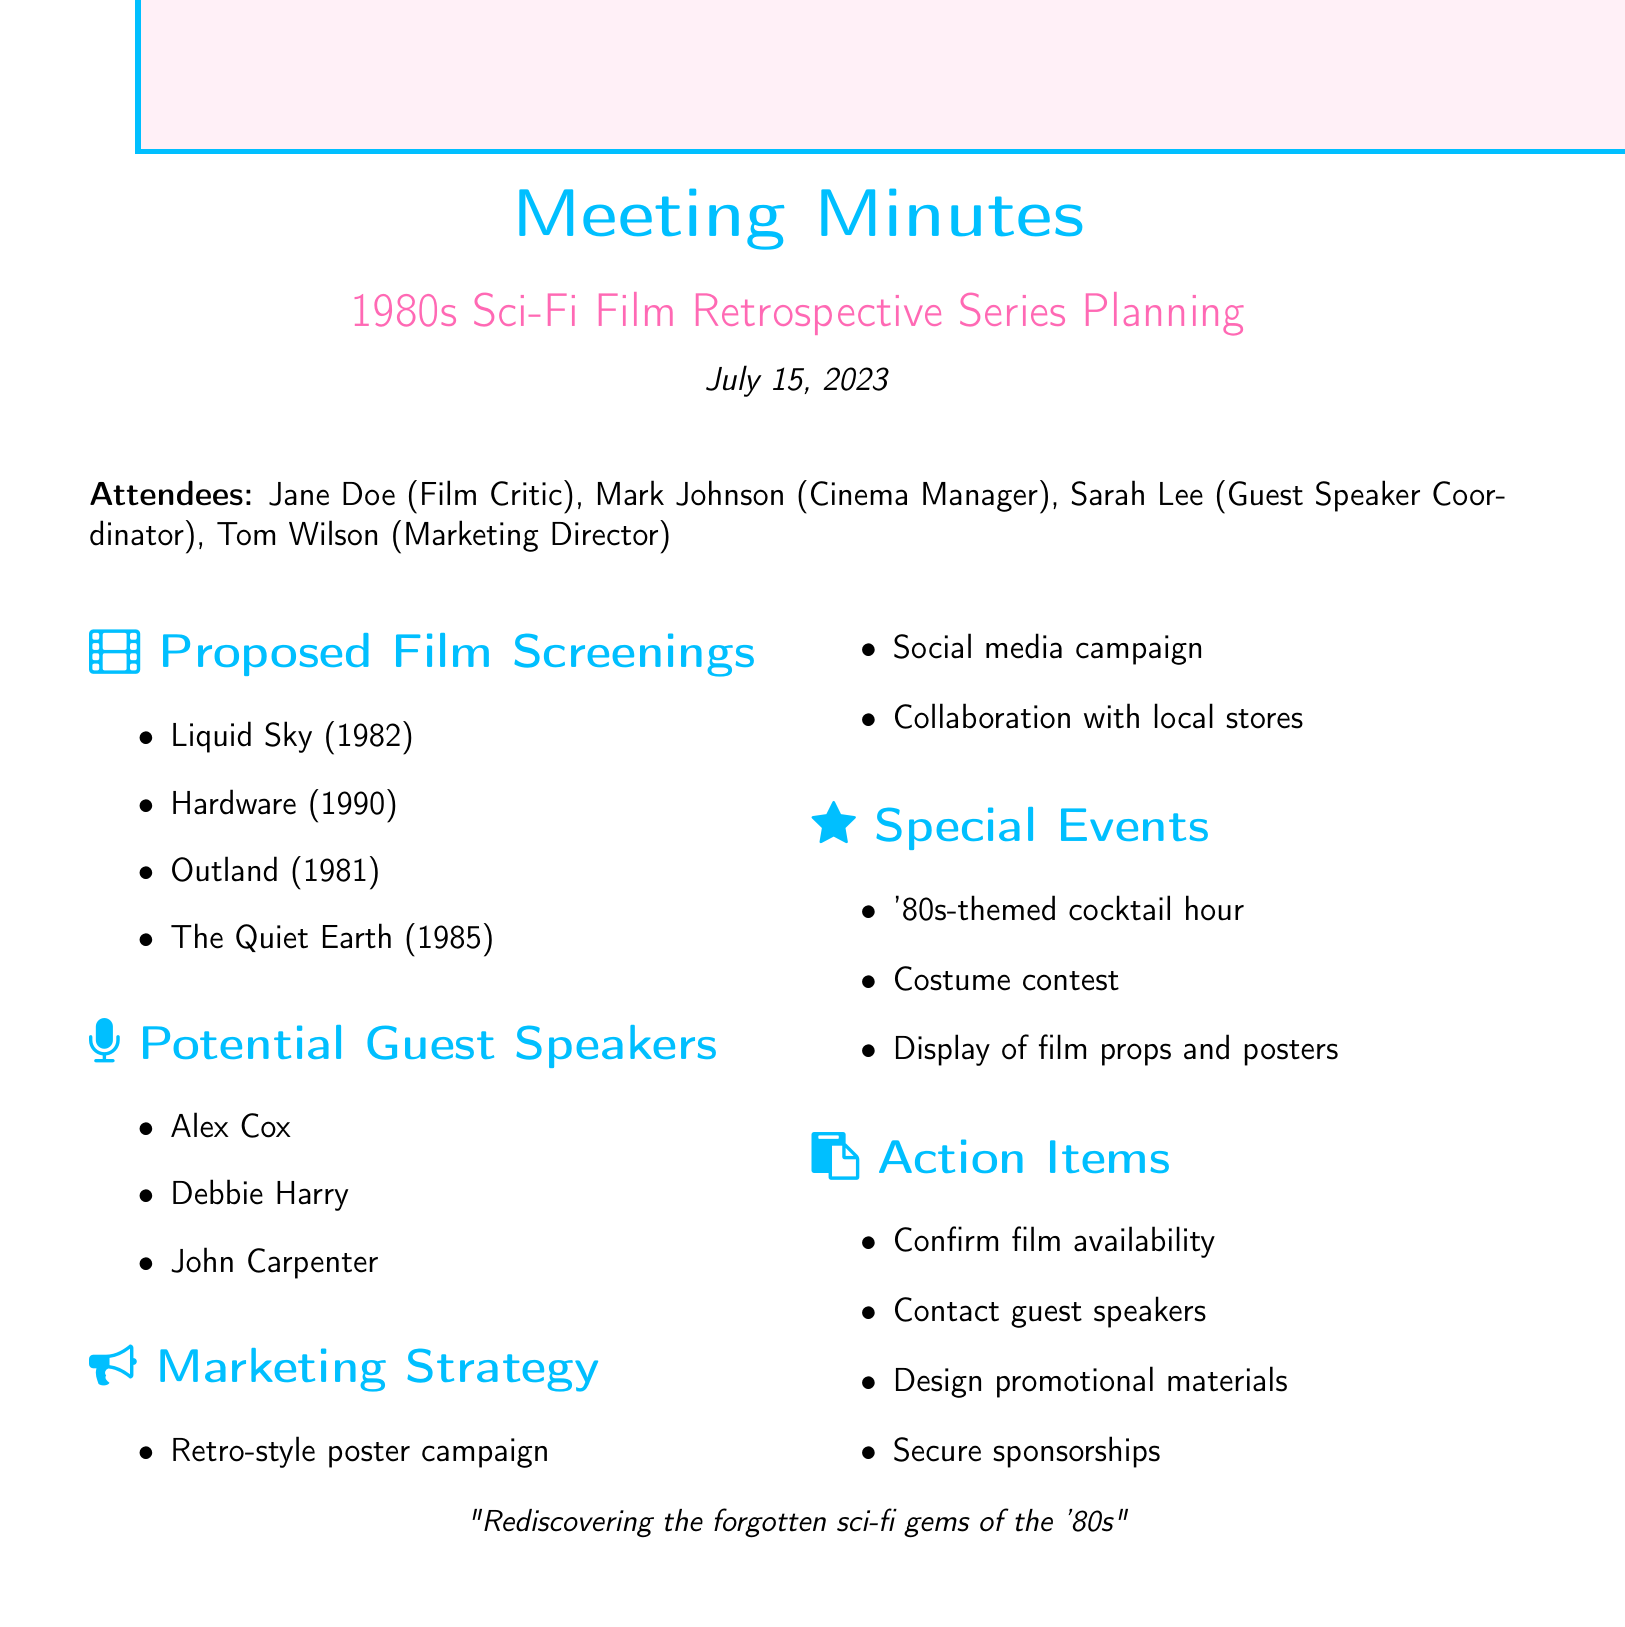what is the date of the meeting? The date of the meeting is explicitly stated in the document as July 15, 2023.
Answer: July 15, 2023 who is the cinema manager? The document lists Mark Johnson as the cinema manager among the attendees.
Answer: Mark Johnson how many films are proposed for screening? The document lists four films under the proposed film screenings section.
Answer: Four which film was released in 1982? The proposed film screenings section of the document includes Liquid Sky which was released in 1982.
Answer: Liquid Sky who is the lead singer of Blondie? Debbie Harry is mentioned in the document as the lead singer of Blondie and a potential guest speaker.
Answer: Debbie Harry what is one of the special events planned for the retrospective? The document mentions a costume contest as one of the special events planned for the retrospective series.
Answer: Costume contest how many guests are proposed as speakers? Three potential guest speakers are specified in the document.
Answer: Three what type of marketing campaign is proposed? The document specifies a retro-style poster campaign as part of the marketing strategy.
Answer: Retro-style poster campaign what action item involves contacting agents? The action item regarding guest speakers mentions reaching out to potential guest speakers through their agents.
Answer: Reach out to potential guest speakers 